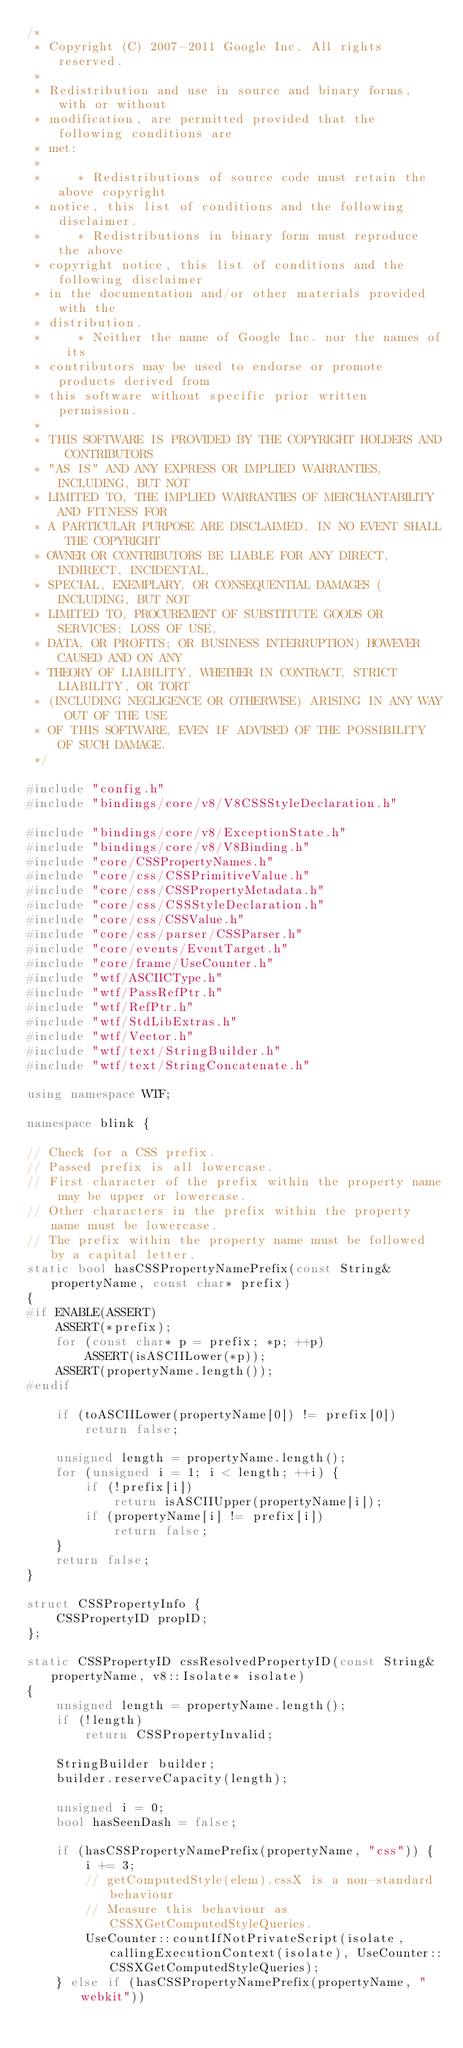<code> <loc_0><loc_0><loc_500><loc_500><_C++_>/*
 * Copyright (C) 2007-2011 Google Inc. All rights reserved.
 *
 * Redistribution and use in source and binary forms, with or without
 * modification, are permitted provided that the following conditions are
 * met:
 *
 *     * Redistributions of source code must retain the above copyright
 * notice, this list of conditions and the following disclaimer.
 *     * Redistributions in binary form must reproduce the above
 * copyright notice, this list of conditions and the following disclaimer
 * in the documentation and/or other materials provided with the
 * distribution.
 *     * Neither the name of Google Inc. nor the names of its
 * contributors may be used to endorse or promote products derived from
 * this software without specific prior written permission.
 *
 * THIS SOFTWARE IS PROVIDED BY THE COPYRIGHT HOLDERS AND CONTRIBUTORS
 * "AS IS" AND ANY EXPRESS OR IMPLIED WARRANTIES, INCLUDING, BUT NOT
 * LIMITED TO, THE IMPLIED WARRANTIES OF MERCHANTABILITY AND FITNESS FOR
 * A PARTICULAR PURPOSE ARE DISCLAIMED. IN NO EVENT SHALL THE COPYRIGHT
 * OWNER OR CONTRIBUTORS BE LIABLE FOR ANY DIRECT, INDIRECT, INCIDENTAL,
 * SPECIAL, EXEMPLARY, OR CONSEQUENTIAL DAMAGES (INCLUDING, BUT NOT
 * LIMITED TO, PROCUREMENT OF SUBSTITUTE GOODS OR SERVICES; LOSS OF USE,
 * DATA, OR PROFITS; OR BUSINESS INTERRUPTION) HOWEVER CAUSED AND ON ANY
 * THEORY OF LIABILITY, WHETHER IN CONTRACT, STRICT LIABILITY, OR TORT
 * (INCLUDING NEGLIGENCE OR OTHERWISE) ARISING IN ANY WAY OUT OF THE USE
 * OF THIS SOFTWARE, EVEN IF ADVISED OF THE POSSIBILITY OF SUCH DAMAGE.
 */

#include "config.h"
#include "bindings/core/v8/V8CSSStyleDeclaration.h"

#include "bindings/core/v8/ExceptionState.h"
#include "bindings/core/v8/V8Binding.h"
#include "core/CSSPropertyNames.h"
#include "core/css/CSSPrimitiveValue.h"
#include "core/css/CSSPropertyMetadata.h"
#include "core/css/CSSStyleDeclaration.h"
#include "core/css/CSSValue.h"
#include "core/css/parser/CSSParser.h"
#include "core/events/EventTarget.h"
#include "core/frame/UseCounter.h"
#include "wtf/ASCIICType.h"
#include "wtf/PassRefPtr.h"
#include "wtf/RefPtr.h"
#include "wtf/StdLibExtras.h"
#include "wtf/Vector.h"
#include "wtf/text/StringBuilder.h"
#include "wtf/text/StringConcatenate.h"

using namespace WTF;

namespace blink {

// Check for a CSS prefix.
// Passed prefix is all lowercase.
// First character of the prefix within the property name may be upper or lowercase.
// Other characters in the prefix within the property name must be lowercase.
// The prefix within the property name must be followed by a capital letter.
static bool hasCSSPropertyNamePrefix(const String& propertyName, const char* prefix)
{
#if ENABLE(ASSERT)
    ASSERT(*prefix);
    for (const char* p = prefix; *p; ++p)
        ASSERT(isASCIILower(*p));
    ASSERT(propertyName.length());
#endif

    if (toASCIILower(propertyName[0]) != prefix[0])
        return false;

    unsigned length = propertyName.length();
    for (unsigned i = 1; i < length; ++i) {
        if (!prefix[i])
            return isASCIIUpper(propertyName[i]);
        if (propertyName[i] != prefix[i])
            return false;
    }
    return false;
}

struct CSSPropertyInfo {
    CSSPropertyID propID;
};

static CSSPropertyID cssResolvedPropertyID(const String& propertyName, v8::Isolate* isolate)
{
    unsigned length = propertyName.length();
    if (!length)
        return CSSPropertyInvalid;

    StringBuilder builder;
    builder.reserveCapacity(length);

    unsigned i = 0;
    bool hasSeenDash = false;

    if (hasCSSPropertyNamePrefix(propertyName, "css")) {
        i += 3;
        // getComputedStyle(elem).cssX is a non-standard behaviour
        // Measure this behaviour as CSSXGetComputedStyleQueries.
        UseCounter::countIfNotPrivateScript(isolate, callingExecutionContext(isolate), UseCounter::CSSXGetComputedStyleQueries);
    } else if (hasCSSPropertyNamePrefix(propertyName, "webkit"))</code> 